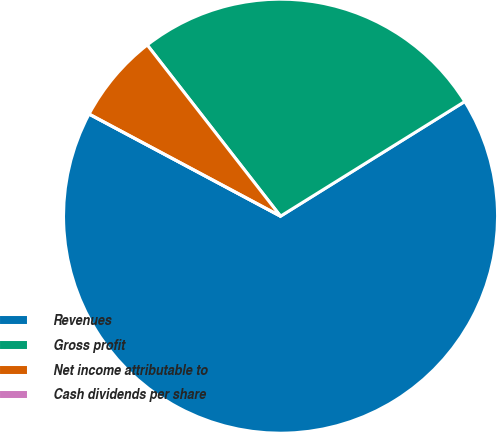<chart> <loc_0><loc_0><loc_500><loc_500><pie_chart><fcel>Revenues<fcel>Gross profit<fcel>Net income attributable to<fcel>Cash dividends per share<nl><fcel>66.66%<fcel>26.67%<fcel>6.67%<fcel>0.0%<nl></chart> 